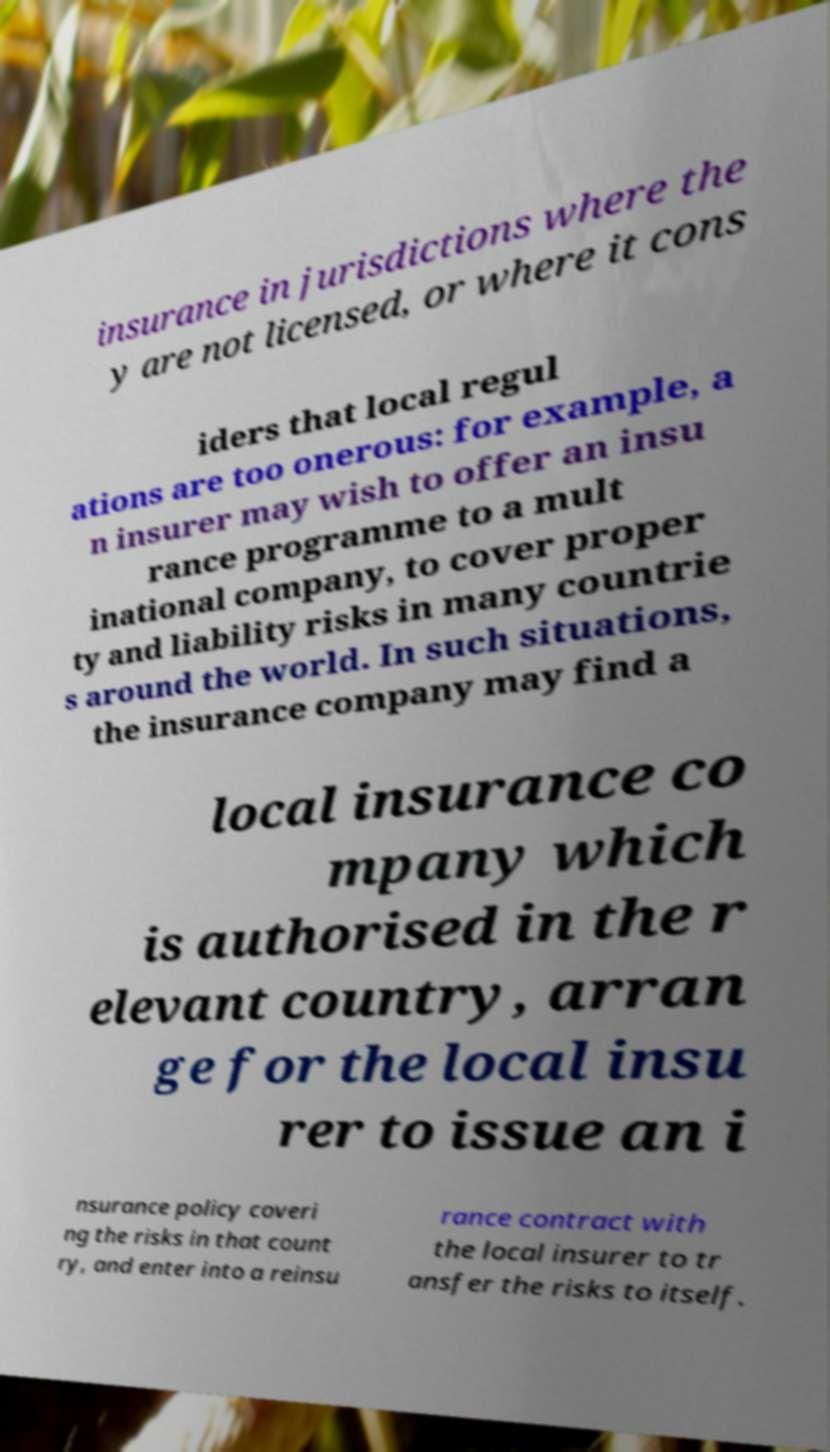Can you read and provide the text displayed in the image?This photo seems to have some interesting text. Can you extract and type it out for me? insurance in jurisdictions where the y are not licensed, or where it cons iders that local regul ations are too onerous: for example, a n insurer may wish to offer an insu rance programme to a mult inational company, to cover proper ty and liability risks in many countrie s around the world. In such situations, the insurance company may find a local insurance co mpany which is authorised in the r elevant country, arran ge for the local insu rer to issue an i nsurance policy coveri ng the risks in that count ry, and enter into a reinsu rance contract with the local insurer to tr ansfer the risks to itself. 